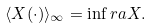<formula> <loc_0><loc_0><loc_500><loc_500>\langle X ( \cdot ) \rangle _ { \infty } = \inf r a { X } .</formula> 